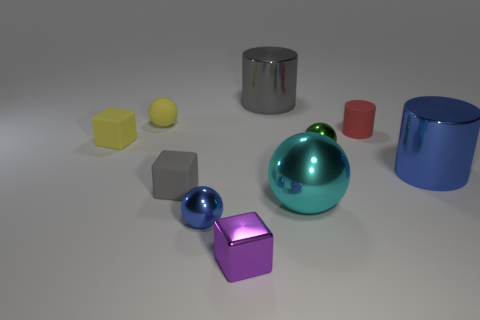Subtract all green balls. How many balls are left? 3 Subtract all blue balls. How many balls are left? 3 Subtract 2 spheres. How many spheres are left? 2 Subtract all spheres. How many objects are left? 6 Subtract all brown spheres. Subtract all yellow cubes. How many spheres are left? 4 Subtract all tiny blocks. Subtract all tiny red matte cylinders. How many objects are left? 6 Add 5 small yellow rubber cubes. How many small yellow rubber cubes are left? 6 Add 7 cubes. How many cubes exist? 10 Subtract 0 brown cylinders. How many objects are left? 10 